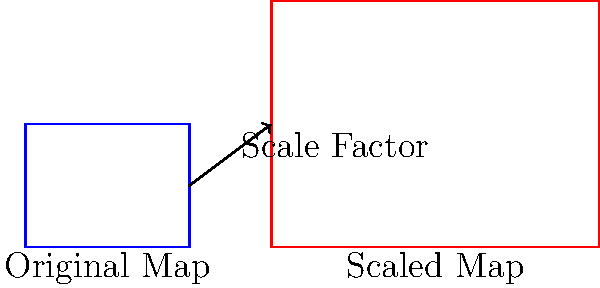A map of earthquake-affected areas needs to be scaled up for better resource distribution planning. The original map measures 4 units wide and 3 units tall. If the scaled map has a width of 8 units, what is the area of the scaled map in square units? Let's approach this step-by-step:

1) First, we need to determine the scale factor:
   New width / Original width = Scale factor
   $8 / 4 = 2$

2) The scale factor is 2, meaning all dimensions are doubled.

3) If the width is doubled, the height will also be doubled:
   Original height: 3 units
   Scaled height: $3 * 2 = 6$ units

4) Now we know the dimensions of the scaled map:
   Width: 8 units
   Height: 6 units

5) To find the area, we multiply width by height:
   Area = $8 * 6 = 48$ square units

Therefore, the area of the scaled map is 48 square units.
Answer: 48 square units 